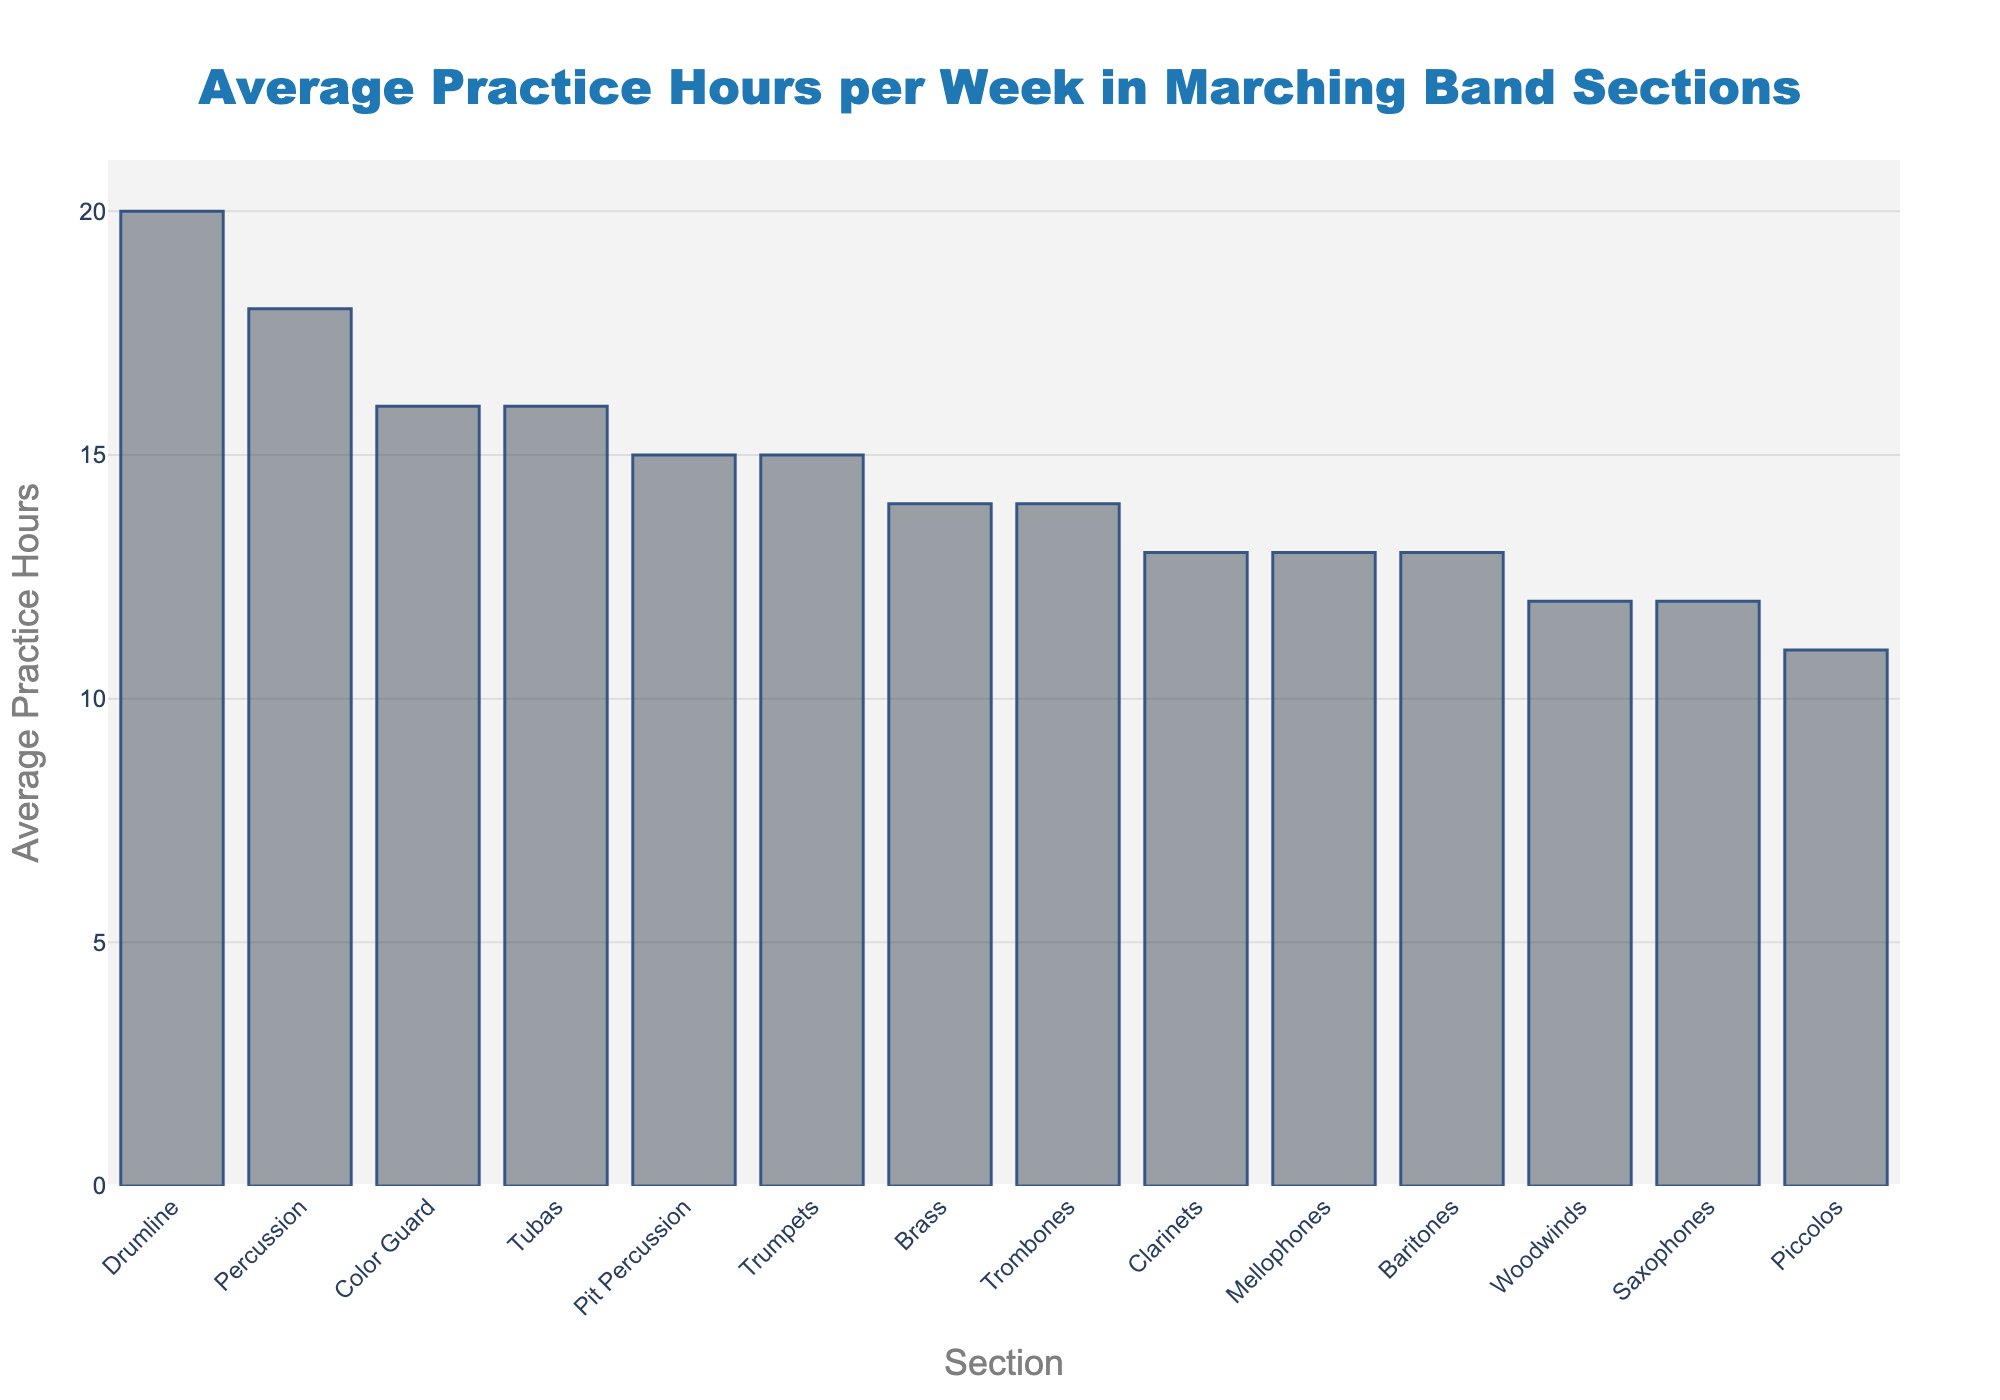What section has the highest average practice hours? Look at the bar that reaches the highest value on the chart. The Drumline section has the tallest bar extending up to 20 average practice hours per week.
Answer: Drumline Which section practices more, Brass or Pit Percussion? Compare the heights of the bars for Brass and Pit Percussion. The bar for Pit Percussion (15 hours) is higher than the bar for Brass (14 hours).
Answer: Pit Percussion What is the difference in average practice hours between the section that practices the most and the section that practices the least? The Drumline practices the most with 20 hours, and Piccolos practice the least with 11 hours. The difference is 20 - 11.
Answer: 9 How many sections practice more than 15 hours per week? Count the number of bars that extend above the 15-hour mark. The sections are Drumline, Percussion, Color Guard, and Tubas.
Answer: 4 What is the combined average practice hours of the Clarinets and the Saxophones? Add the average practice hours for Clarinets (13 hours) and Saxophones (12 hours).
Answer: 25 Do the Mellophones and Baritones practice an equal number of hours per week? Compare the heights (values) of the bars for Mellophones and Baritones. Both sections practice 13 hours per week.
Answer: Yes Which section practices fewer hours, Trombones or Tubas? Compare the heights of the bars for Trombones and Tubas. The bar for Trombones (14 hours) is lower than the bar for Tubas (16 hours).
Answer: Trombones By how many hours does the Drumline exceed the Percussion in practice hours? Subtract the average practice hours of Percussion (18 hours) from Drumline (20 hours).
Answer: 2 What is the average practice time for sections that practice between 12 and 14 hours per week? Identify sections (Woodwinds, Saxophones, Brass, Mellophones, Trombones, Baritones) and their values: 12, 12, 14, 13, 14, 13. Sum them (12 + 12 + 14 + 13 + 14 + 13 = 78) and divide by 6.
Answer: 13 Which practices more on average, Tubas or Color Guard? Compare the heights of the bars for Tubas and Color Guard. Both sections practice 16 hours per week.
Answer: Equal 